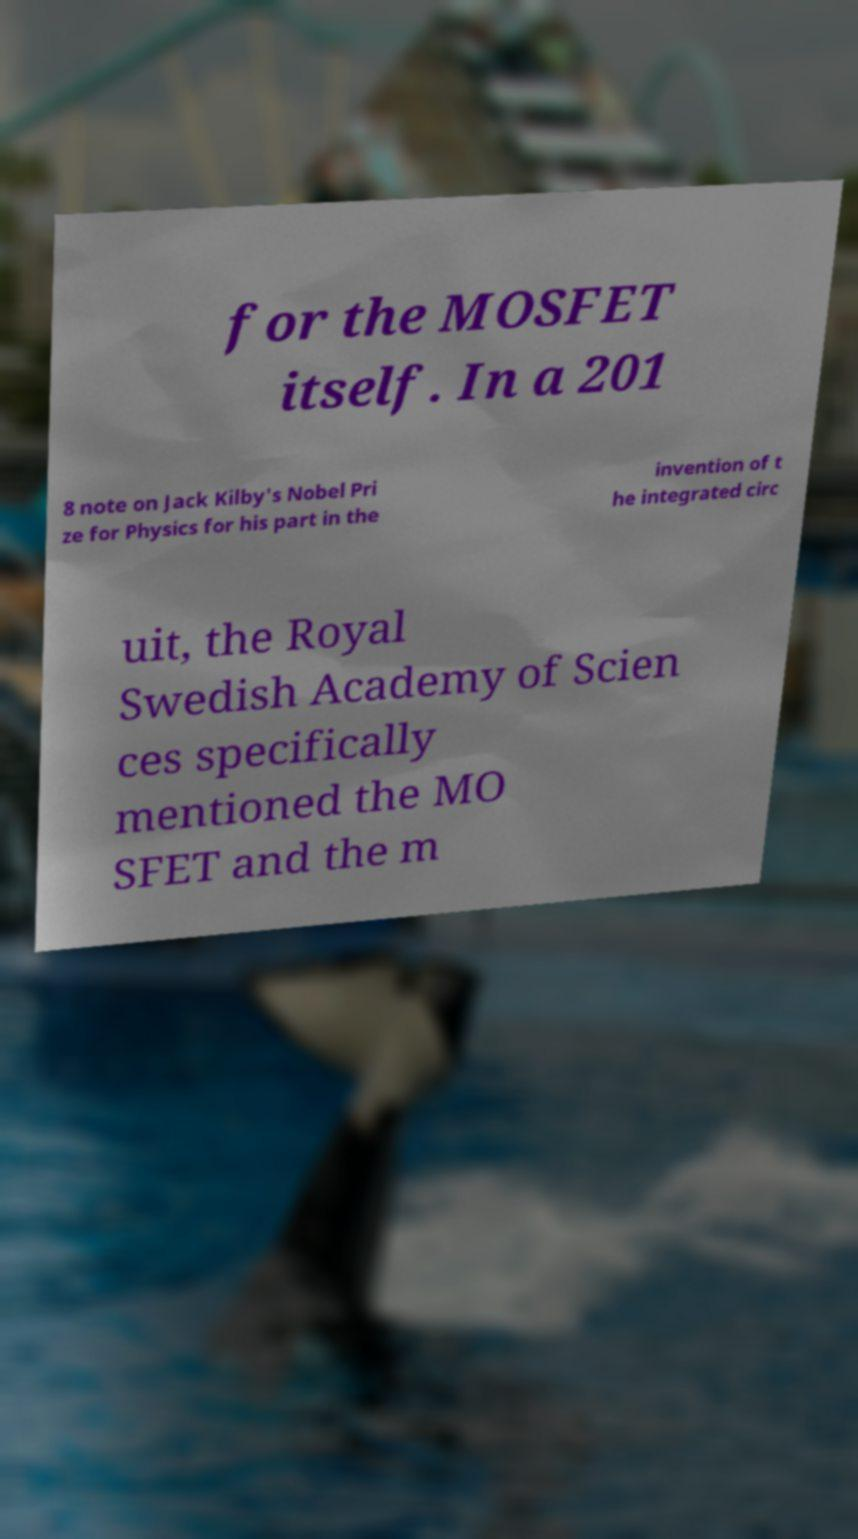What messages or text are displayed in this image? I need them in a readable, typed format. for the MOSFET itself. In a 201 8 note on Jack Kilby's Nobel Pri ze for Physics for his part in the invention of t he integrated circ uit, the Royal Swedish Academy of Scien ces specifically mentioned the MO SFET and the m 